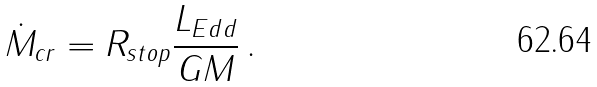Convert formula to latex. <formula><loc_0><loc_0><loc_500><loc_500>\dot { M } _ { c r } = R _ { s t o p } \frac { L _ { E d d } } { G M } \, .</formula> 